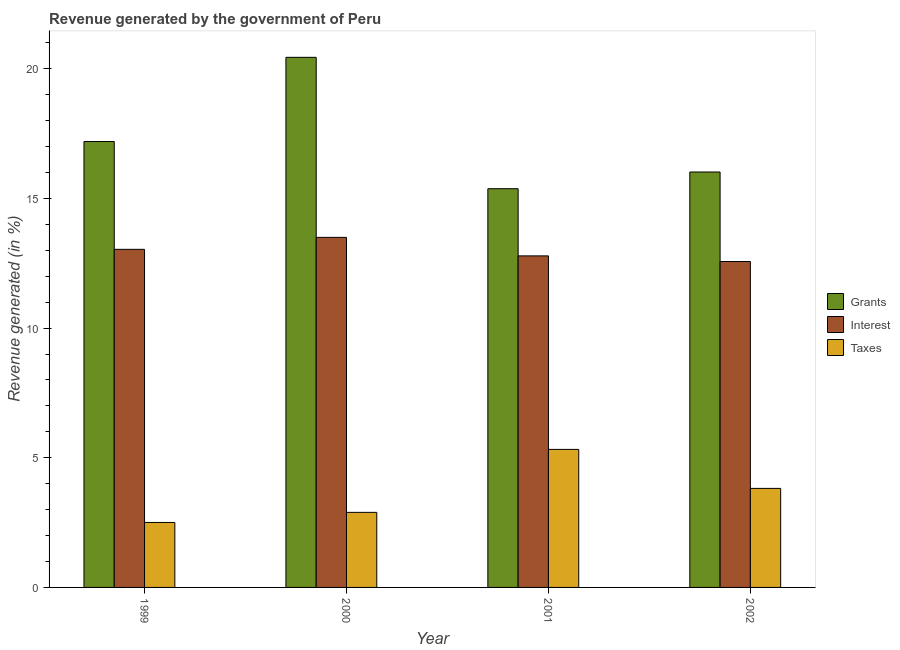How many different coloured bars are there?
Your answer should be very brief. 3. Are the number of bars per tick equal to the number of legend labels?
Make the answer very short. Yes. Are the number of bars on each tick of the X-axis equal?
Your answer should be compact. Yes. How many bars are there on the 4th tick from the right?
Your answer should be very brief. 3. What is the label of the 3rd group of bars from the left?
Give a very brief answer. 2001. What is the percentage of revenue generated by grants in 2000?
Offer a very short reply. 20.44. Across all years, what is the maximum percentage of revenue generated by taxes?
Your answer should be very brief. 5.32. Across all years, what is the minimum percentage of revenue generated by taxes?
Your answer should be very brief. 2.51. In which year was the percentage of revenue generated by grants maximum?
Give a very brief answer. 2000. What is the total percentage of revenue generated by grants in the graph?
Offer a terse response. 69.04. What is the difference between the percentage of revenue generated by grants in 1999 and that in 2002?
Provide a succinct answer. 1.17. What is the difference between the percentage of revenue generated by interest in 1999 and the percentage of revenue generated by grants in 2001?
Offer a terse response. 0.25. What is the average percentage of revenue generated by grants per year?
Your answer should be compact. 17.26. In the year 2001, what is the difference between the percentage of revenue generated by taxes and percentage of revenue generated by interest?
Your response must be concise. 0. What is the ratio of the percentage of revenue generated by interest in 2000 to that in 2002?
Offer a terse response. 1.07. Is the percentage of revenue generated by interest in 1999 less than that in 2000?
Your answer should be very brief. Yes. What is the difference between the highest and the second highest percentage of revenue generated by interest?
Ensure brevity in your answer.  0.46. What is the difference between the highest and the lowest percentage of revenue generated by grants?
Keep it short and to the point. 5.07. In how many years, is the percentage of revenue generated by taxes greater than the average percentage of revenue generated by taxes taken over all years?
Your answer should be very brief. 2. Is the sum of the percentage of revenue generated by interest in 1999 and 2001 greater than the maximum percentage of revenue generated by taxes across all years?
Give a very brief answer. Yes. What does the 3rd bar from the left in 1999 represents?
Ensure brevity in your answer.  Taxes. What does the 3rd bar from the right in 2000 represents?
Provide a short and direct response. Grants. Is it the case that in every year, the sum of the percentage of revenue generated by grants and percentage of revenue generated by interest is greater than the percentage of revenue generated by taxes?
Make the answer very short. Yes. Are all the bars in the graph horizontal?
Offer a very short reply. No. Does the graph contain any zero values?
Ensure brevity in your answer.  No. Where does the legend appear in the graph?
Ensure brevity in your answer.  Center right. How many legend labels are there?
Offer a terse response. 3. What is the title of the graph?
Offer a terse response. Revenue generated by the government of Peru. Does "Natural Gas" appear as one of the legend labels in the graph?
Your answer should be compact. No. What is the label or title of the Y-axis?
Give a very brief answer. Revenue generated (in %). What is the Revenue generated (in %) of Grants in 1999?
Keep it short and to the point. 17.2. What is the Revenue generated (in %) of Interest in 1999?
Make the answer very short. 13.04. What is the Revenue generated (in %) in Taxes in 1999?
Provide a short and direct response. 2.51. What is the Revenue generated (in %) in Grants in 2000?
Give a very brief answer. 20.44. What is the Revenue generated (in %) in Interest in 2000?
Keep it short and to the point. 13.5. What is the Revenue generated (in %) of Taxes in 2000?
Provide a succinct answer. 2.89. What is the Revenue generated (in %) of Grants in 2001?
Provide a short and direct response. 15.38. What is the Revenue generated (in %) in Interest in 2001?
Keep it short and to the point. 12.79. What is the Revenue generated (in %) of Taxes in 2001?
Keep it short and to the point. 5.32. What is the Revenue generated (in %) of Grants in 2002?
Provide a short and direct response. 16.02. What is the Revenue generated (in %) in Interest in 2002?
Give a very brief answer. 12.57. What is the Revenue generated (in %) of Taxes in 2002?
Provide a succinct answer. 3.82. Across all years, what is the maximum Revenue generated (in %) in Grants?
Ensure brevity in your answer.  20.44. Across all years, what is the maximum Revenue generated (in %) in Interest?
Keep it short and to the point. 13.5. Across all years, what is the maximum Revenue generated (in %) of Taxes?
Keep it short and to the point. 5.32. Across all years, what is the minimum Revenue generated (in %) of Grants?
Provide a succinct answer. 15.38. Across all years, what is the minimum Revenue generated (in %) in Interest?
Provide a succinct answer. 12.57. Across all years, what is the minimum Revenue generated (in %) in Taxes?
Your response must be concise. 2.51. What is the total Revenue generated (in %) of Grants in the graph?
Ensure brevity in your answer.  69.04. What is the total Revenue generated (in %) in Interest in the graph?
Give a very brief answer. 51.9. What is the total Revenue generated (in %) of Taxes in the graph?
Make the answer very short. 14.54. What is the difference between the Revenue generated (in %) of Grants in 1999 and that in 2000?
Make the answer very short. -3.25. What is the difference between the Revenue generated (in %) in Interest in 1999 and that in 2000?
Keep it short and to the point. -0.46. What is the difference between the Revenue generated (in %) of Taxes in 1999 and that in 2000?
Ensure brevity in your answer.  -0.39. What is the difference between the Revenue generated (in %) of Grants in 1999 and that in 2001?
Your answer should be compact. 1.82. What is the difference between the Revenue generated (in %) in Interest in 1999 and that in 2001?
Offer a terse response. 0.25. What is the difference between the Revenue generated (in %) of Taxes in 1999 and that in 2001?
Give a very brief answer. -2.82. What is the difference between the Revenue generated (in %) of Grants in 1999 and that in 2002?
Your answer should be very brief. 1.17. What is the difference between the Revenue generated (in %) in Interest in 1999 and that in 2002?
Offer a very short reply. 0.47. What is the difference between the Revenue generated (in %) in Taxes in 1999 and that in 2002?
Your response must be concise. -1.31. What is the difference between the Revenue generated (in %) in Grants in 2000 and that in 2001?
Your response must be concise. 5.07. What is the difference between the Revenue generated (in %) of Interest in 2000 and that in 2001?
Ensure brevity in your answer.  0.71. What is the difference between the Revenue generated (in %) in Taxes in 2000 and that in 2001?
Offer a terse response. -2.43. What is the difference between the Revenue generated (in %) of Grants in 2000 and that in 2002?
Make the answer very short. 4.42. What is the difference between the Revenue generated (in %) in Interest in 2000 and that in 2002?
Your answer should be very brief. 0.93. What is the difference between the Revenue generated (in %) in Taxes in 2000 and that in 2002?
Provide a short and direct response. -0.92. What is the difference between the Revenue generated (in %) of Grants in 2001 and that in 2002?
Your answer should be very brief. -0.64. What is the difference between the Revenue generated (in %) in Interest in 2001 and that in 2002?
Give a very brief answer. 0.22. What is the difference between the Revenue generated (in %) in Taxes in 2001 and that in 2002?
Make the answer very short. 1.5. What is the difference between the Revenue generated (in %) in Grants in 1999 and the Revenue generated (in %) in Interest in 2000?
Your answer should be very brief. 3.7. What is the difference between the Revenue generated (in %) in Grants in 1999 and the Revenue generated (in %) in Taxes in 2000?
Offer a terse response. 14.3. What is the difference between the Revenue generated (in %) of Interest in 1999 and the Revenue generated (in %) of Taxes in 2000?
Give a very brief answer. 10.14. What is the difference between the Revenue generated (in %) of Grants in 1999 and the Revenue generated (in %) of Interest in 2001?
Your answer should be compact. 4.41. What is the difference between the Revenue generated (in %) in Grants in 1999 and the Revenue generated (in %) in Taxes in 2001?
Your answer should be compact. 11.87. What is the difference between the Revenue generated (in %) of Interest in 1999 and the Revenue generated (in %) of Taxes in 2001?
Keep it short and to the point. 7.72. What is the difference between the Revenue generated (in %) in Grants in 1999 and the Revenue generated (in %) in Interest in 2002?
Make the answer very short. 4.63. What is the difference between the Revenue generated (in %) in Grants in 1999 and the Revenue generated (in %) in Taxes in 2002?
Make the answer very short. 13.38. What is the difference between the Revenue generated (in %) of Interest in 1999 and the Revenue generated (in %) of Taxes in 2002?
Offer a very short reply. 9.22. What is the difference between the Revenue generated (in %) in Grants in 2000 and the Revenue generated (in %) in Interest in 2001?
Offer a terse response. 7.66. What is the difference between the Revenue generated (in %) in Grants in 2000 and the Revenue generated (in %) in Taxes in 2001?
Your answer should be very brief. 15.12. What is the difference between the Revenue generated (in %) of Interest in 2000 and the Revenue generated (in %) of Taxes in 2001?
Your answer should be very brief. 8.18. What is the difference between the Revenue generated (in %) of Grants in 2000 and the Revenue generated (in %) of Interest in 2002?
Make the answer very short. 7.88. What is the difference between the Revenue generated (in %) in Grants in 2000 and the Revenue generated (in %) in Taxes in 2002?
Provide a short and direct response. 16.63. What is the difference between the Revenue generated (in %) of Interest in 2000 and the Revenue generated (in %) of Taxes in 2002?
Your response must be concise. 9.68. What is the difference between the Revenue generated (in %) of Grants in 2001 and the Revenue generated (in %) of Interest in 2002?
Provide a succinct answer. 2.81. What is the difference between the Revenue generated (in %) of Grants in 2001 and the Revenue generated (in %) of Taxes in 2002?
Offer a very short reply. 11.56. What is the difference between the Revenue generated (in %) in Interest in 2001 and the Revenue generated (in %) in Taxes in 2002?
Provide a succinct answer. 8.97. What is the average Revenue generated (in %) in Grants per year?
Provide a succinct answer. 17.26. What is the average Revenue generated (in %) of Interest per year?
Provide a succinct answer. 12.97. What is the average Revenue generated (in %) of Taxes per year?
Give a very brief answer. 3.64. In the year 1999, what is the difference between the Revenue generated (in %) in Grants and Revenue generated (in %) in Interest?
Make the answer very short. 4.16. In the year 1999, what is the difference between the Revenue generated (in %) of Grants and Revenue generated (in %) of Taxes?
Offer a very short reply. 14.69. In the year 1999, what is the difference between the Revenue generated (in %) in Interest and Revenue generated (in %) in Taxes?
Offer a very short reply. 10.53. In the year 2000, what is the difference between the Revenue generated (in %) in Grants and Revenue generated (in %) in Interest?
Keep it short and to the point. 6.94. In the year 2000, what is the difference between the Revenue generated (in %) in Grants and Revenue generated (in %) in Taxes?
Offer a terse response. 17.55. In the year 2000, what is the difference between the Revenue generated (in %) of Interest and Revenue generated (in %) of Taxes?
Offer a terse response. 10.61. In the year 2001, what is the difference between the Revenue generated (in %) of Grants and Revenue generated (in %) of Interest?
Your answer should be very brief. 2.59. In the year 2001, what is the difference between the Revenue generated (in %) of Grants and Revenue generated (in %) of Taxes?
Offer a very short reply. 10.05. In the year 2001, what is the difference between the Revenue generated (in %) of Interest and Revenue generated (in %) of Taxes?
Make the answer very short. 7.46. In the year 2002, what is the difference between the Revenue generated (in %) of Grants and Revenue generated (in %) of Interest?
Your response must be concise. 3.45. In the year 2002, what is the difference between the Revenue generated (in %) of Grants and Revenue generated (in %) of Taxes?
Keep it short and to the point. 12.2. In the year 2002, what is the difference between the Revenue generated (in %) in Interest and Revenue generated (in %) in Taxes?
Provide a short and direct response. 8.75. What is the ratio of the Revenue generated (in %) of Grants in 1999 to that in 2000?
Keep it short and to the point. 0.84. What is the ratio of the Revenue generated (in %) of Interest in 1999 to that in 2000?
Your answer should be compact. 0.97. What is the ratio of the Revenue generated (in %) of Taxes in 1999 to that in 2000?
Your answer should be compact. 0.87. What is the ratio of the Revenue generated (in %) of Grants in 1999 to that in 2001?
Make the answer very short. 1.12. What is the ratio of the Revenue generated (in %) in Interest in 1999 to that in 2001?
Your response must be concise. 1.02. What is the ratio of the Revenue generated (in %) of Taxes in 1999 to that in 2001?
Make the answer very short. 0.47. What is the ratio of the Revenue generated (in %) of Grants in 1999 to that in 2002?
Provide a succinct answer. 1.07. What is the ratio of the Revenue generated (in %) in Interest in 1999 to that in 2002?
Your answer should be compact. 1.04. What is the ratio of the Revenue generated (in %) of Taxes in 1999 to that in 2002?
Provide a short and direct response. 0.66. What is the ratio of the Revenue generated (in %) in Grants in 2000 to that in 2001?
Your answer should be very brief. 1.33. What is the ratio of the Revenue generated (in %) in Interest in 2000 to that in 2001?
Offer a very short reply. 1.06. What is the ratio of the Revenue generated (in %) in Taxes in 2000 to that in 2001?
Your response must be concise. 0.54. What is the ratio of the Revenue generated (in %) in Grants in 2000 to that in 2002?
Give a very brief answer. 1.28. What is the ratio of the Revenue generated (in %) of Interest in 2000 to that in 2002?
Make the answer very short. 1.07. What is the ratio of the Revenue generated (in %) in Taxes in 2000 to that in 2002?
Keep it short and to the point. 0.76. What is the ratio of the Revenue generated (in %) of Grants in 2001 to that in 2002?
Keep it short and to the point. 0.96. What is the ratio of the Revenue generated (in %) of Interest in 2001 to that in 2002?
Your answer should be compact. 1.02. What is the ratio of the Revenue generated (in %) of Taxes in 2001 to that in 2002?
Provide a succinct answer. 1.39. What is the difference between the highest and the second highest Revenue generated (in %) in Grants?
Provide a succinct answer. 3.25. What is the difference between the highest and the second highest Revenue generated (in %) in Interest?
Provide a short and direct response. 0.46. What is the difference between the highest and the second highest Revenue generated (in %) in Taxes?
Offer a terse response. 1.5. What is the difference between the highest and the lowest Revenue generated (in %) of Grants?
Provide a short and direct response. 5.07. What is the difference between the highest and the lowest Revenue generated (in %) in Interest?
Your answer should be very brief. 0.93. What is the difference between the highest and the lowest Revenue generated (in %) of Taxes?
Ensure brevity in your answer.  2.82. 